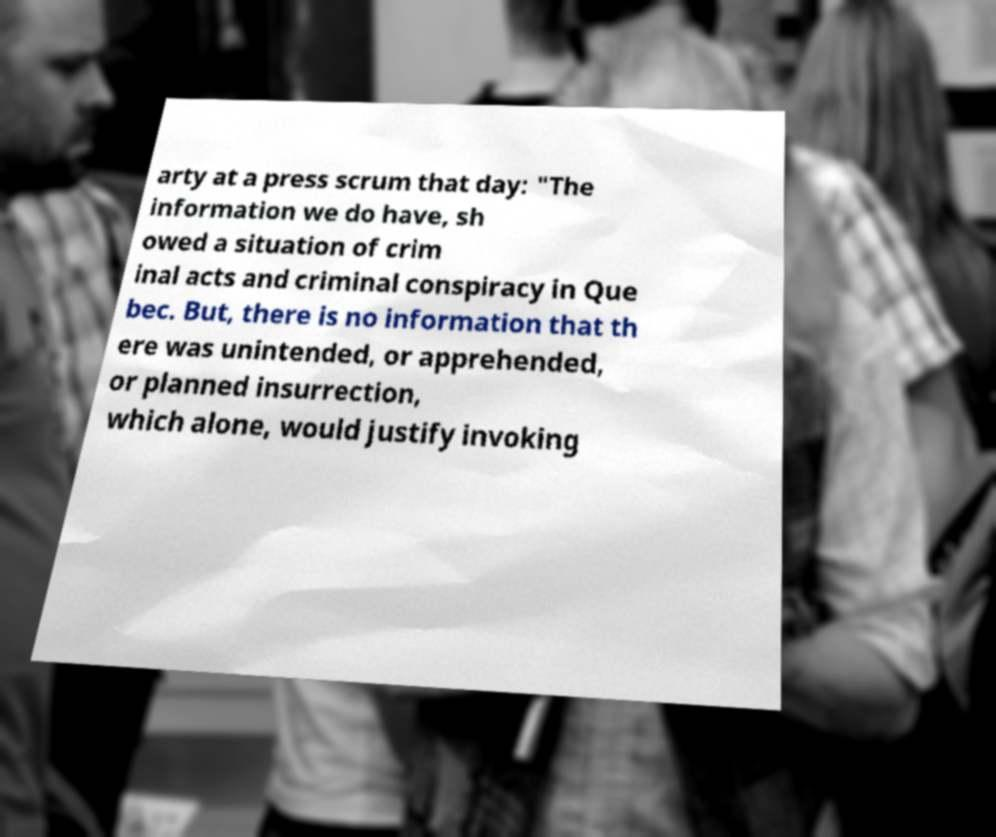There's text embedded in this image that I need extracted. Can you transcribe it verbatim? arty at a press scrum that day: "The information we do have, sh owed a situation of crim inal acts and criminal conspiracy in Que bec. But, there is no information that th ere was unintended, or apprehended, or planned insurrection, which alone, would justify invoking 